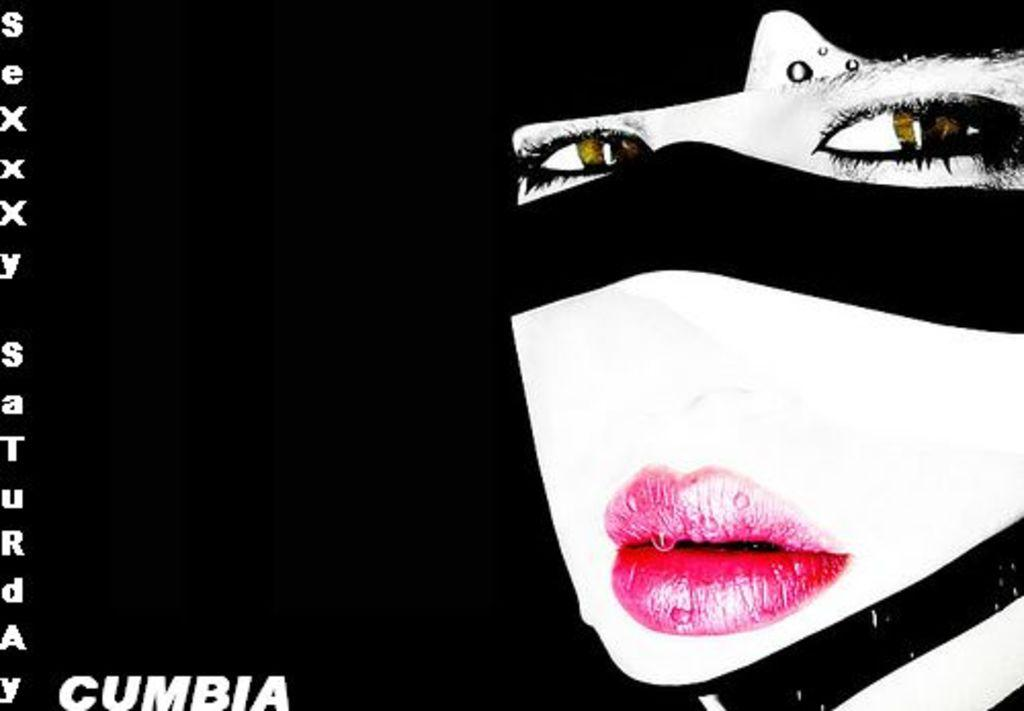What type of visual is the image? The image is a poster. What is depicted on the poster? There is a person's face on the poster. What color is the background of the poster? The background of the poster is black. Are there any words on the poster? Yes, there is text on the poster. Can you see any poisonous substances near the person's face on the poster? There is no mention of poisonous substances in the image, and the image only shows a person's face on a black background with text. Is there a drum visible in the image? There is no drum present in the image; it only features a person's face, a black background, and text. 